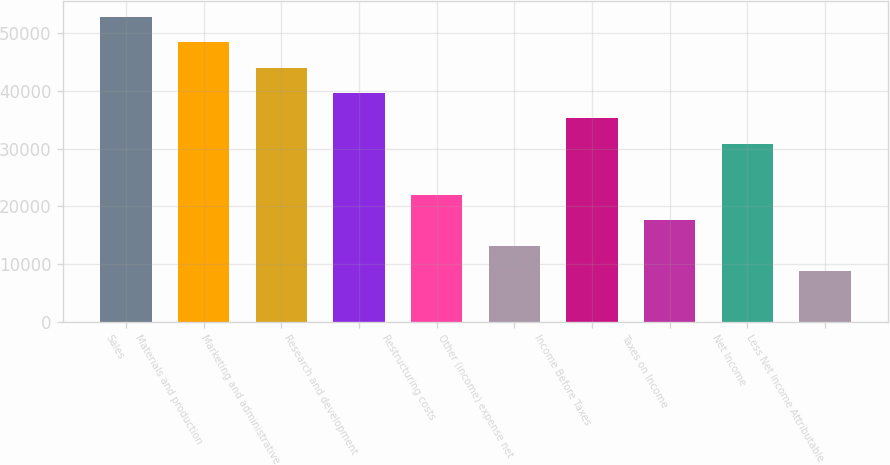Convert chart to OTSL. <chart><loc_0><loc_0><loc_500><loc_500><bar_chart><fcel>Sales<fcel>Materials and production<fcel>Marketing and administrative<fcel>Research and development<fcel>Restructuring costs<fcel>Other (income) expense net<fcel>Income Before Taxes<fcel>Taxes on Income<fcel>Net Income<fcel>Less Net Income Attributable<nl><fcel>52839.3<fcel>48436.1<fcel>44033<fcel>39629.8<fcel>22017.2<fcel>13210.9<fcel>35226.7<fcel>17614.1<fcel>30823.5<fcel>8807.77<nl></chart> 